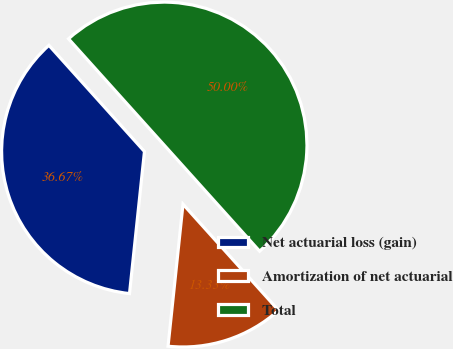Convert chart to OTSL. <chart><loc_0><loc_0><loc_500><loc_500><pie_chart><fcel>Net actuarial loss (gain)<fcel>Amortization of net actuarial<fcel>Total<nl><fcel>36.67%<fcel>13.33%<fcel>50.0%<nl></chart> 